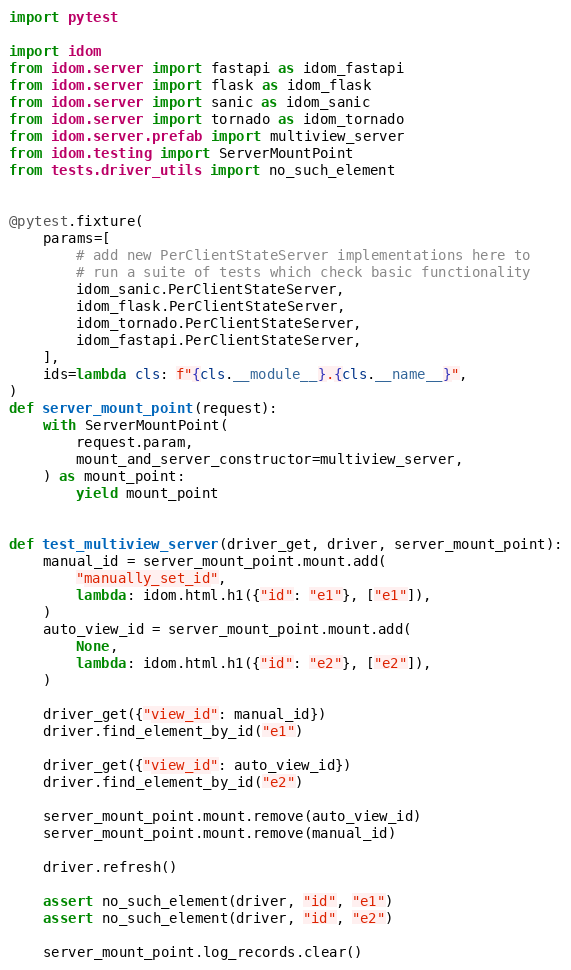<code> <loc_0><loc_0><loc_500><loc_500><_Python_>import pytest

import idom
from idom.server import fastapi as idom_fastapi
from idom.server import flask as idom_flask
from idom.server import sanic as idom_sanic
from idom.server import tornado as idom_tornado
from idom.server.prefab import multiview_server
from idom.testing import ServerMountPoint
from tests.driver_utils import no_such_element


@pytest.fixture(
    params=[
        # add new PerClientStateServer implementations here to
        # run a suite of tests which check basic functionality
        idom_sanic.PerClientStateServer,
        idom_flask.PerClientStateServer,
        idom_tornado.PerClientStateServer,
        idom_fastapi.PerClientStateServer,
    ],
    ids=lambda cls: f"{cls.__module__}.{cls.__name__}",
)
def server_mount_point(request):
    with ServerMountPoint(
        request.param,
        mount_and_server_constructor=multiview_server,
    ) as mount_point:
        yield mount_point


def test_multiview_server(driver_get, driver, server_mount_point):
    manual_id = server_mount_point.mount.add(
        "manually_set_id",
        lambda: idom.html.h1({"id": "e1"}, ["e1"]),
    )
    auto_view_id = server_mount_point.mount.add(
        None,
        lambda: idom.html.h1({"id": "e2"}, ["e2"]),
    )

    driver_get({"view_id": manual_id})
    driver.find_element_by_id("e1")

    driver_get({"view_id": auto_view_id})
    driver.find_element_by_id("e2")

    server_mount_point.mount.remove(auto_view_id)
    server_mount_point.mount.remove(manual_id)

    driver.refresh()

    assert no_such_element(driver, "id", "e1")
    assert no_such_element(driver, "id", "e2")

    server_mount_point.log_records.clear()
</code> 